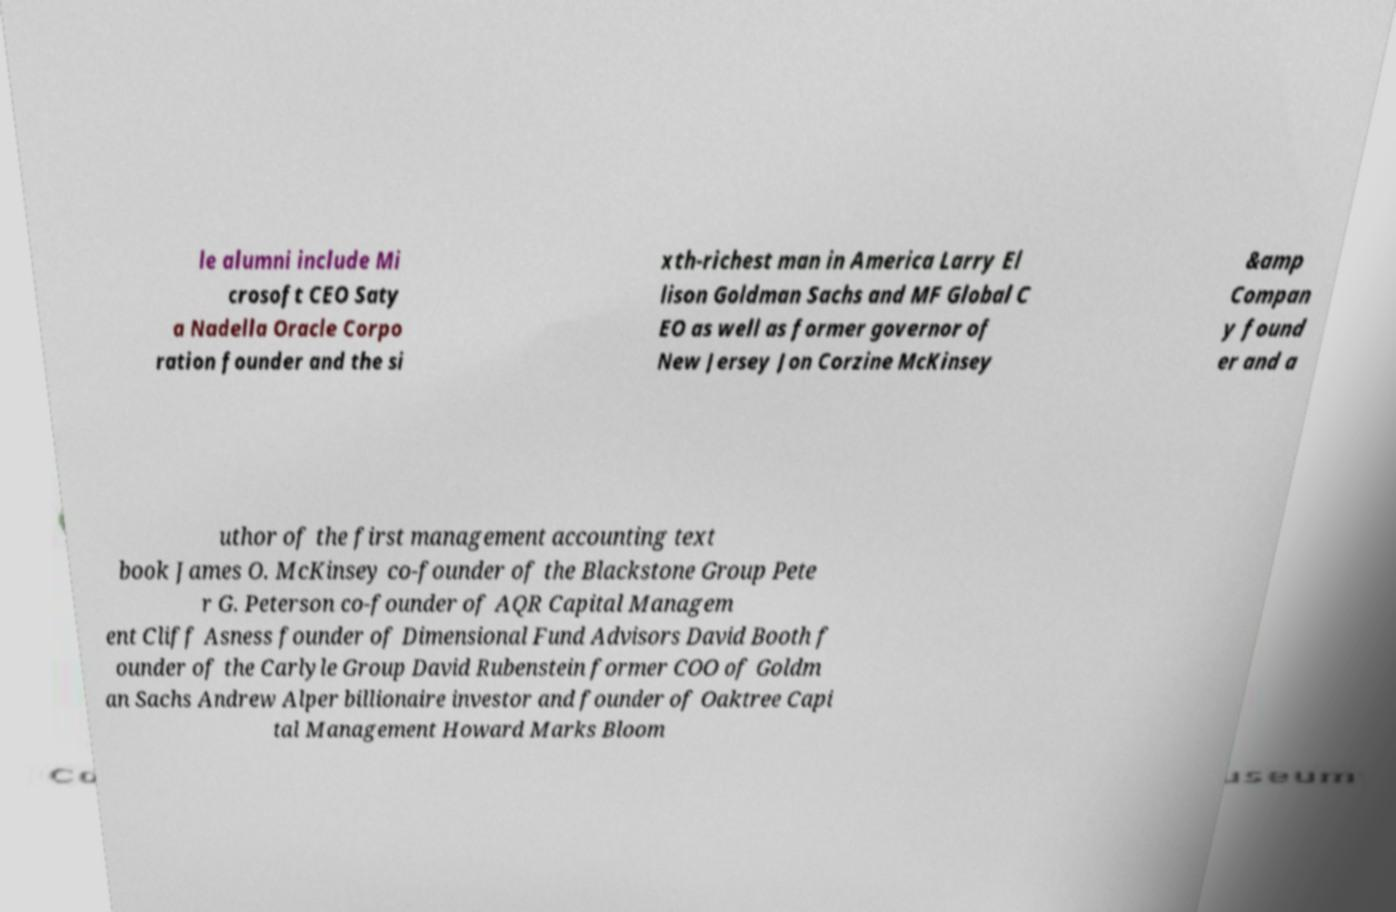Please read and relay the text visible in this image. What does it say? le alumni include Mi crosoft CEO Saty a Nadella Oracle Corpo ration founder and the si xth-richest man in America Larry El lison Goldman Sachs and MF Global C EO as well as former governor of New Jersey Jon Corzine McKinsey &amp Compan y found er and a uthor of the first management accounting text book James O. McKinsey co-founder of the Blackstone Group Pete r G. Peterson co-founder of AQR Capital Managem ent Cliff Asness founder of Dimensional Fund Advisors David Booth f ounder of the Carlyle Group David Rubenstein former COO of Goldm an Sachs Andrew Alper billionaire investor and founder of Oaktree Capi tal Management Howard Marks Bloom 